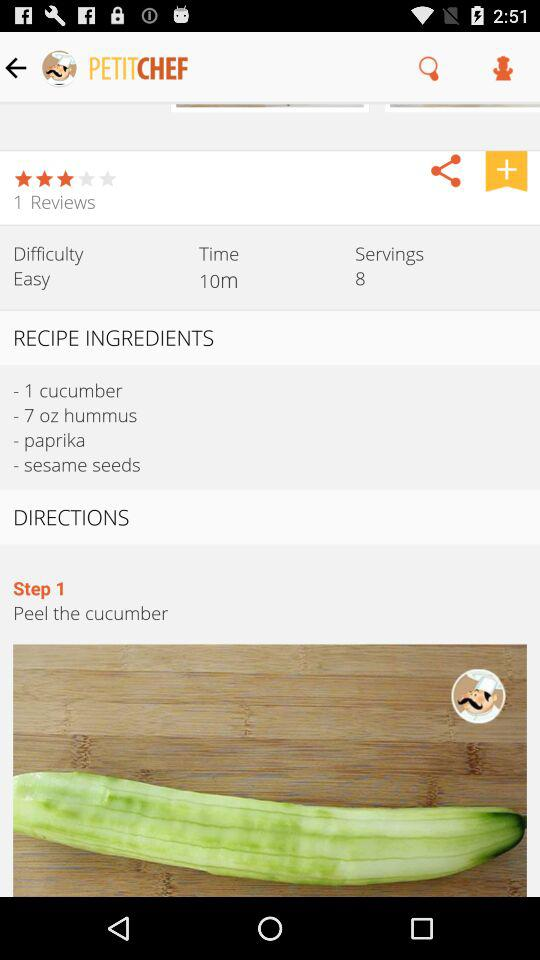What is the name of the application? The name of the application is "PetitChef, cooking and recipes". 